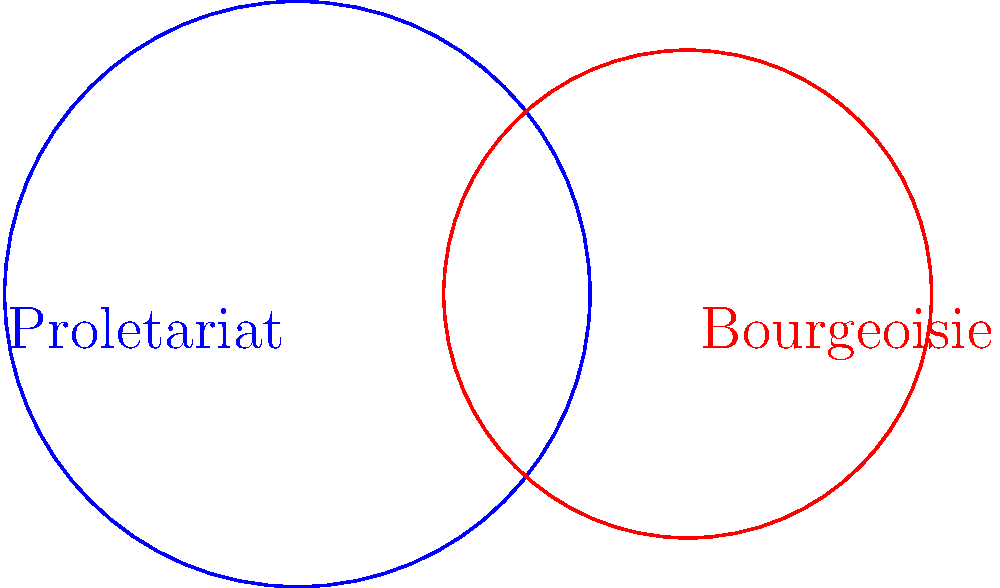In the diagram, two circles represent the ideological spheres of the proletariat and bourgeoisie. The blue circle (proletariat) has a radius of 3 units, while the red circle (bourgeoisie) has a radius of 2.5 units. Their centers are 4 units apart. Calculate the area of the green region representing the convergence of these ideologies. How does this area compare to the total area of the proletariat circle, and what might this suggest about the potential for ideological synthesis in Marxist theory? To solve this problem, we'll follow these steps:

1) First, we need to calculate the area of intersection between the two circles. The formula for this is:

   $$A = r_1^2 \arccos(\frac{d^2 + r_1^2 - r_2^2}{2dr_1}) + r_2^2 \arccos(\frac{d^2 + r_2^2 - r_1^2}{2dr_2}) - \frac{1}{2}\sqrt{(-d+r_1+r_2)(d+r_1-r_2)(d-r_1+r_2)(d+r_1+r_2)}$$

   Where $r_1 = 3$, $r_2 = 2.5$, and $d = 4$ (the distance between centers).

2) Plugging in these values:

   $$A \approx 2.72 \text{ square units}$$

3) The area of the proletariat circle (blue) is:

   $$A_p = \pi r_1^2 = \pi (3^2) \approx 28.27 \text{ square units}$$

4) The ratio of the intersection area to the proletariat circle area is:

   $$\frac{2.72}{28.27} \approx 0.0962 \text{ or about } 9.62\%$$

5) This suggests that about 9.62% of the proletariat's ideological sphere overlaps with the bourgeoisie's.

In Marxist theory, this intersection could represent the potential for ideological synthesis or the areas where proletariat and bourgeoisie interests align. The relatively small overlap (less than 10%) might suggest limited common ground between the two classes, reinforcing the Marxist view of class struggle. However, it also indicates that some level of ideological convergence is possible, which could be explored in developing strategies for social change or understanding the complexities of class relationships.
Answer: 2.72 square units; 9.62% of proletariat circle 